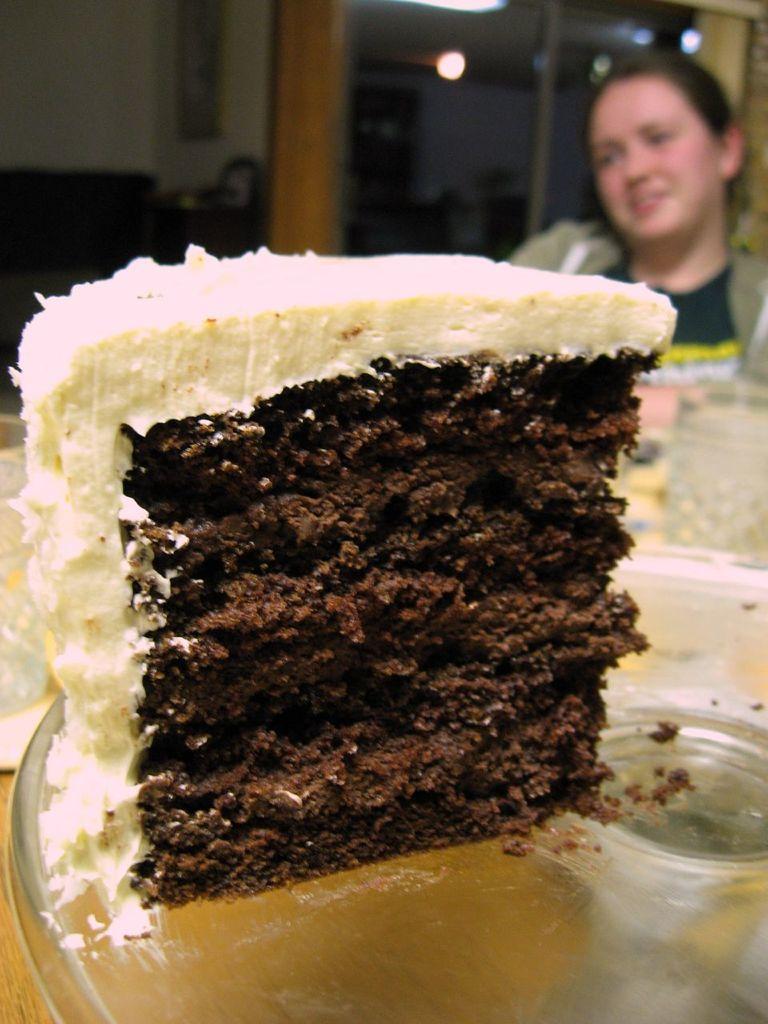How would you summarize this image in a sentence or two? In this image we can see a piece of a cake with cream on the plate and there is a person sitting and a blurry background. 